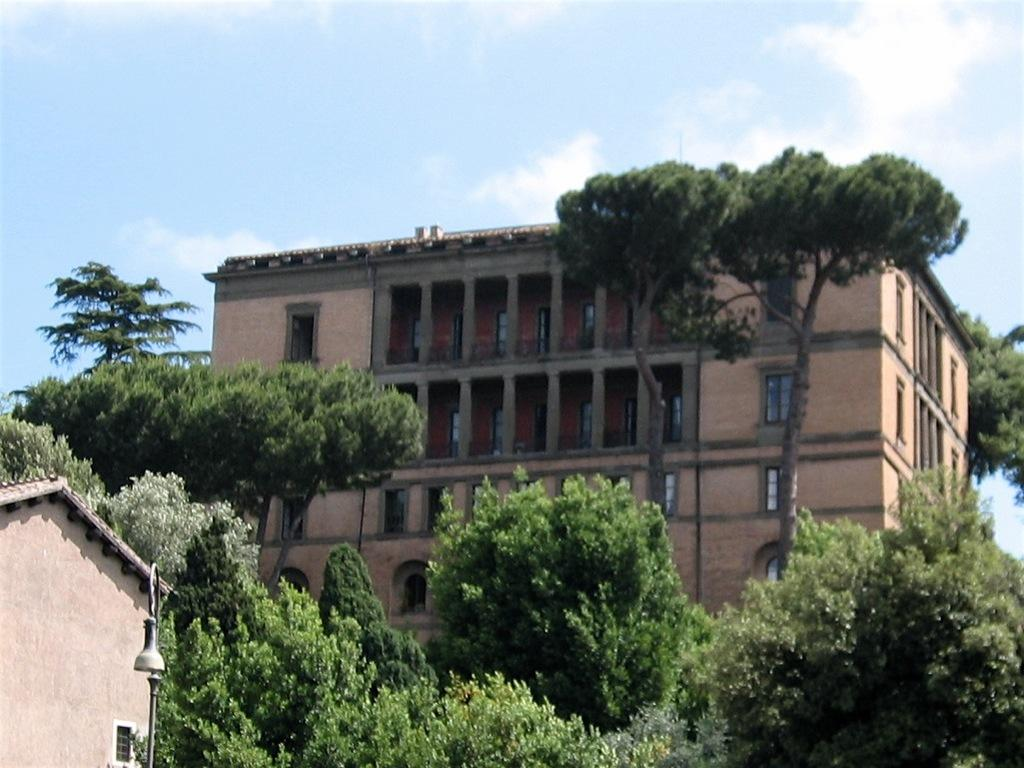What is the main feature of the image? There are many trees in the image. What structure can be seen on the left side of the image? There is a house with light on the left side of the image. What can be seen in the background of the image? There is a building with windows and clouds visible in the background of the image. What is visible above the trees and building in the image? The sky is visible in the background of the image. What type of prose is being taught in the class visible in the image? There is no class visible in the image; it features trees, a house with light, a building with windows, clouds, and the sky. Where is the sofa located in the image? There is no sofa present in the image. 